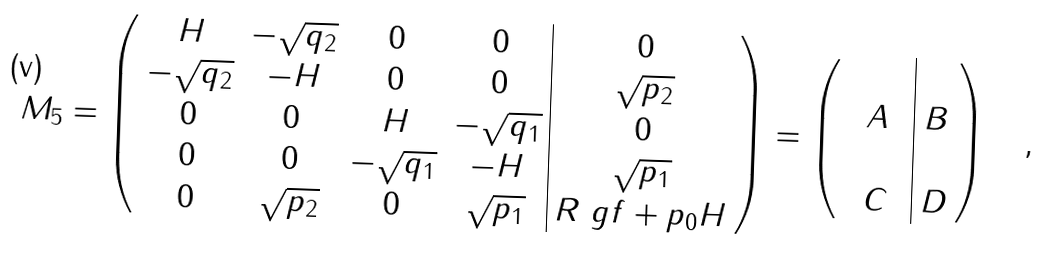<formula> <loc_0><loc_0><loc_500><loc_500>M _ { 5 } = \left ( \begin{array} { c c c c | c } { H } & { - \sqrt { q _ { 2 } } } & 0 & 0 & 0 \\ { - \sqrt { q _ { 2 } } } & { - H } & 0 & 0 & { \sqrt { p _ { 2 } } } \\ 0 & 0 & { H } & { - \sqrt { q _ { 1 } } } & 0 \\ 0 & 0 & { - \sqrt { q _ { 1 } } } & { - H } & { \sqrt { p _ { 1 } } } \\ 0 & { \sqrt { p _ { 2 } } } & 0 & { \sqrt { p _ { 1 } } } & { R \ g f + p _ { 0 } H } \\ \end{array} \right ) = \left ( \begin{array} { c c c | c } & & & \\ & A & & B \\ & & & \\ & C & & D \end{array} \right ) \quad ,</formula> 